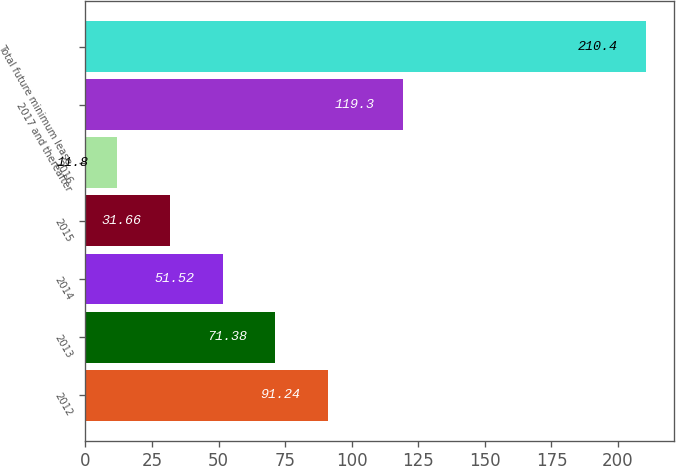Convert chart. <chart><loc_0><loc_0><loc_500><loc_500><bar_chart><fcel>2012<fcel>2013<fcel>2014<fcel>2015<fcel>2016<fcel>2017 and thereafter<fcel>Total future minimum lease<nl><fcel>91.24<fcel>71.38<fcel>51.52<fcel>31.66<fcel>11.8<fcel>119.3<fcel>210.4<nl></chart> 